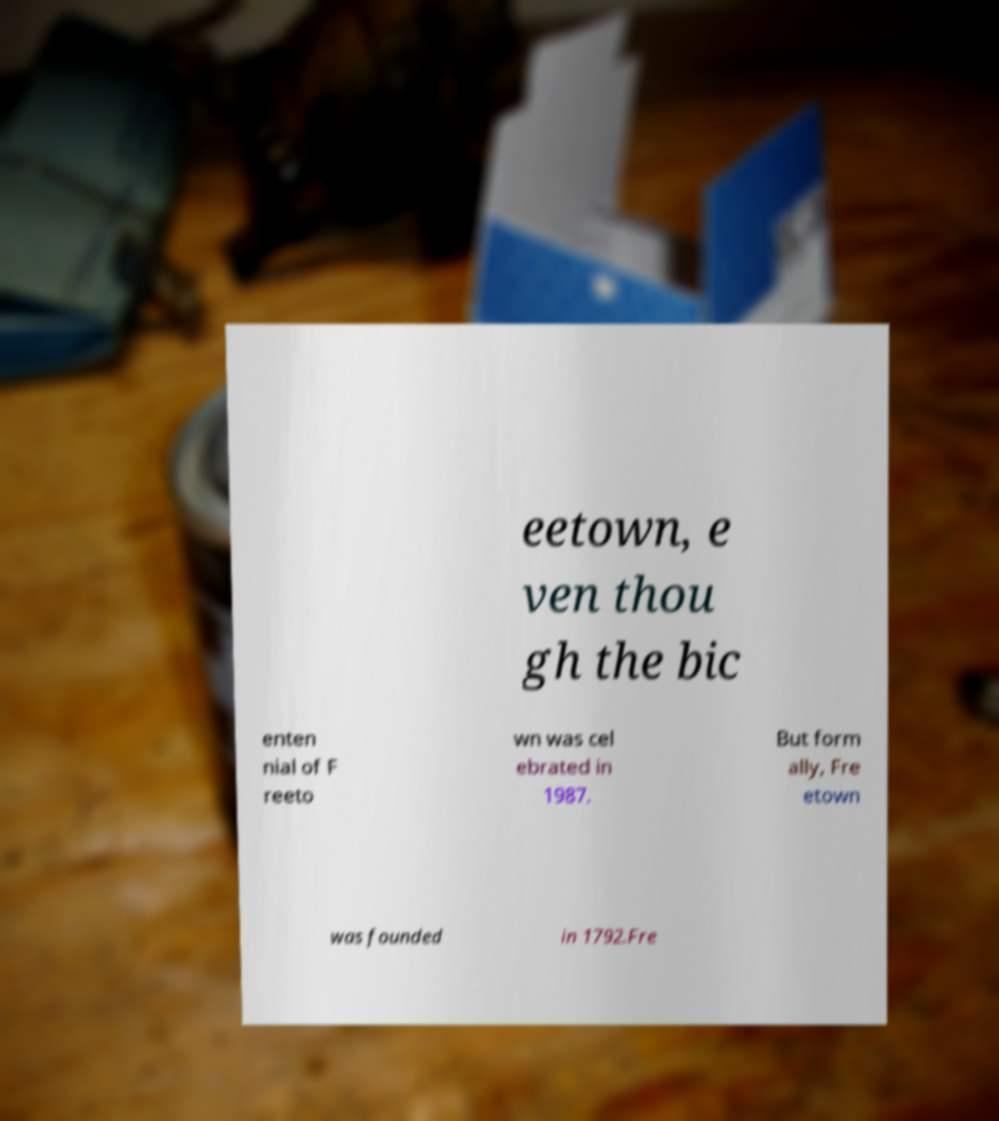Can you accurately transcribe the text from the provided image for me? eetown, e ven thou gh the bic enten nial of F reeto wn was cel ebrated in 1987. But form ally, Fre etown was founded in 1792.Fre 